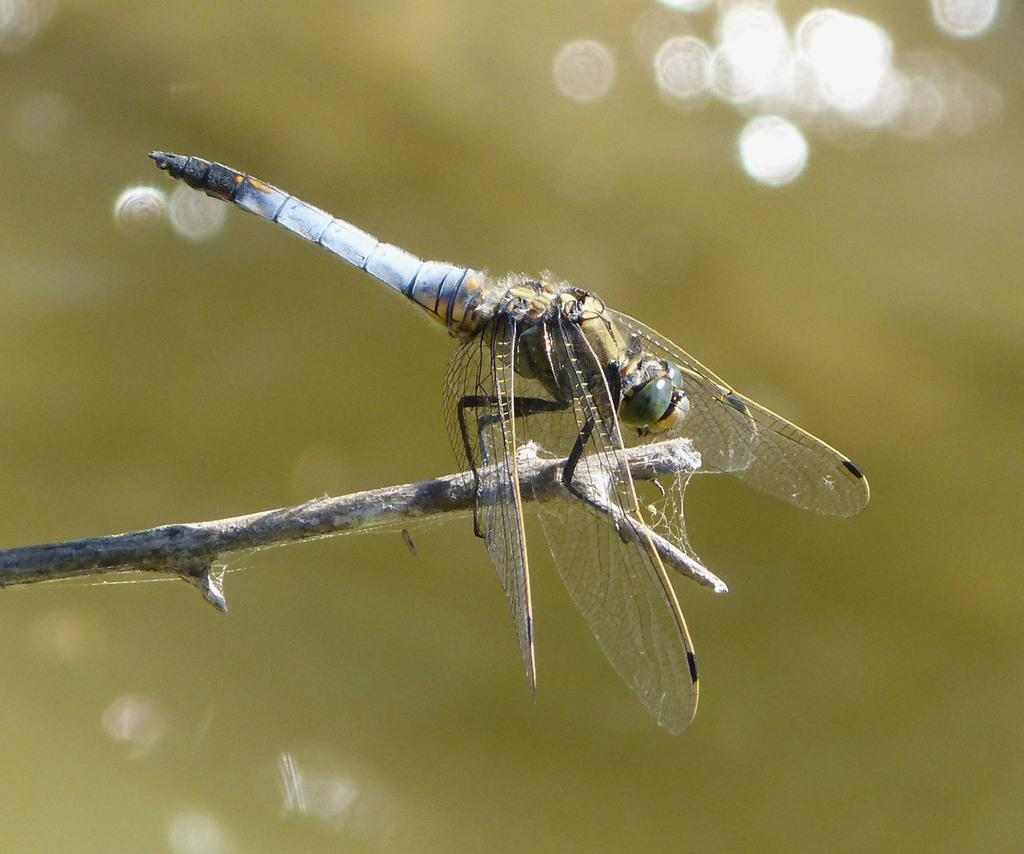What type of insect is in the image? There is a dragonfly in the image. Where is the dragonfly located? The dragonfly is on a twig. What type of drink is the dragonfly holding in the image? The dragonfly is not holding a drink in the image, as dragonflies do not have the ability to hold objects. 